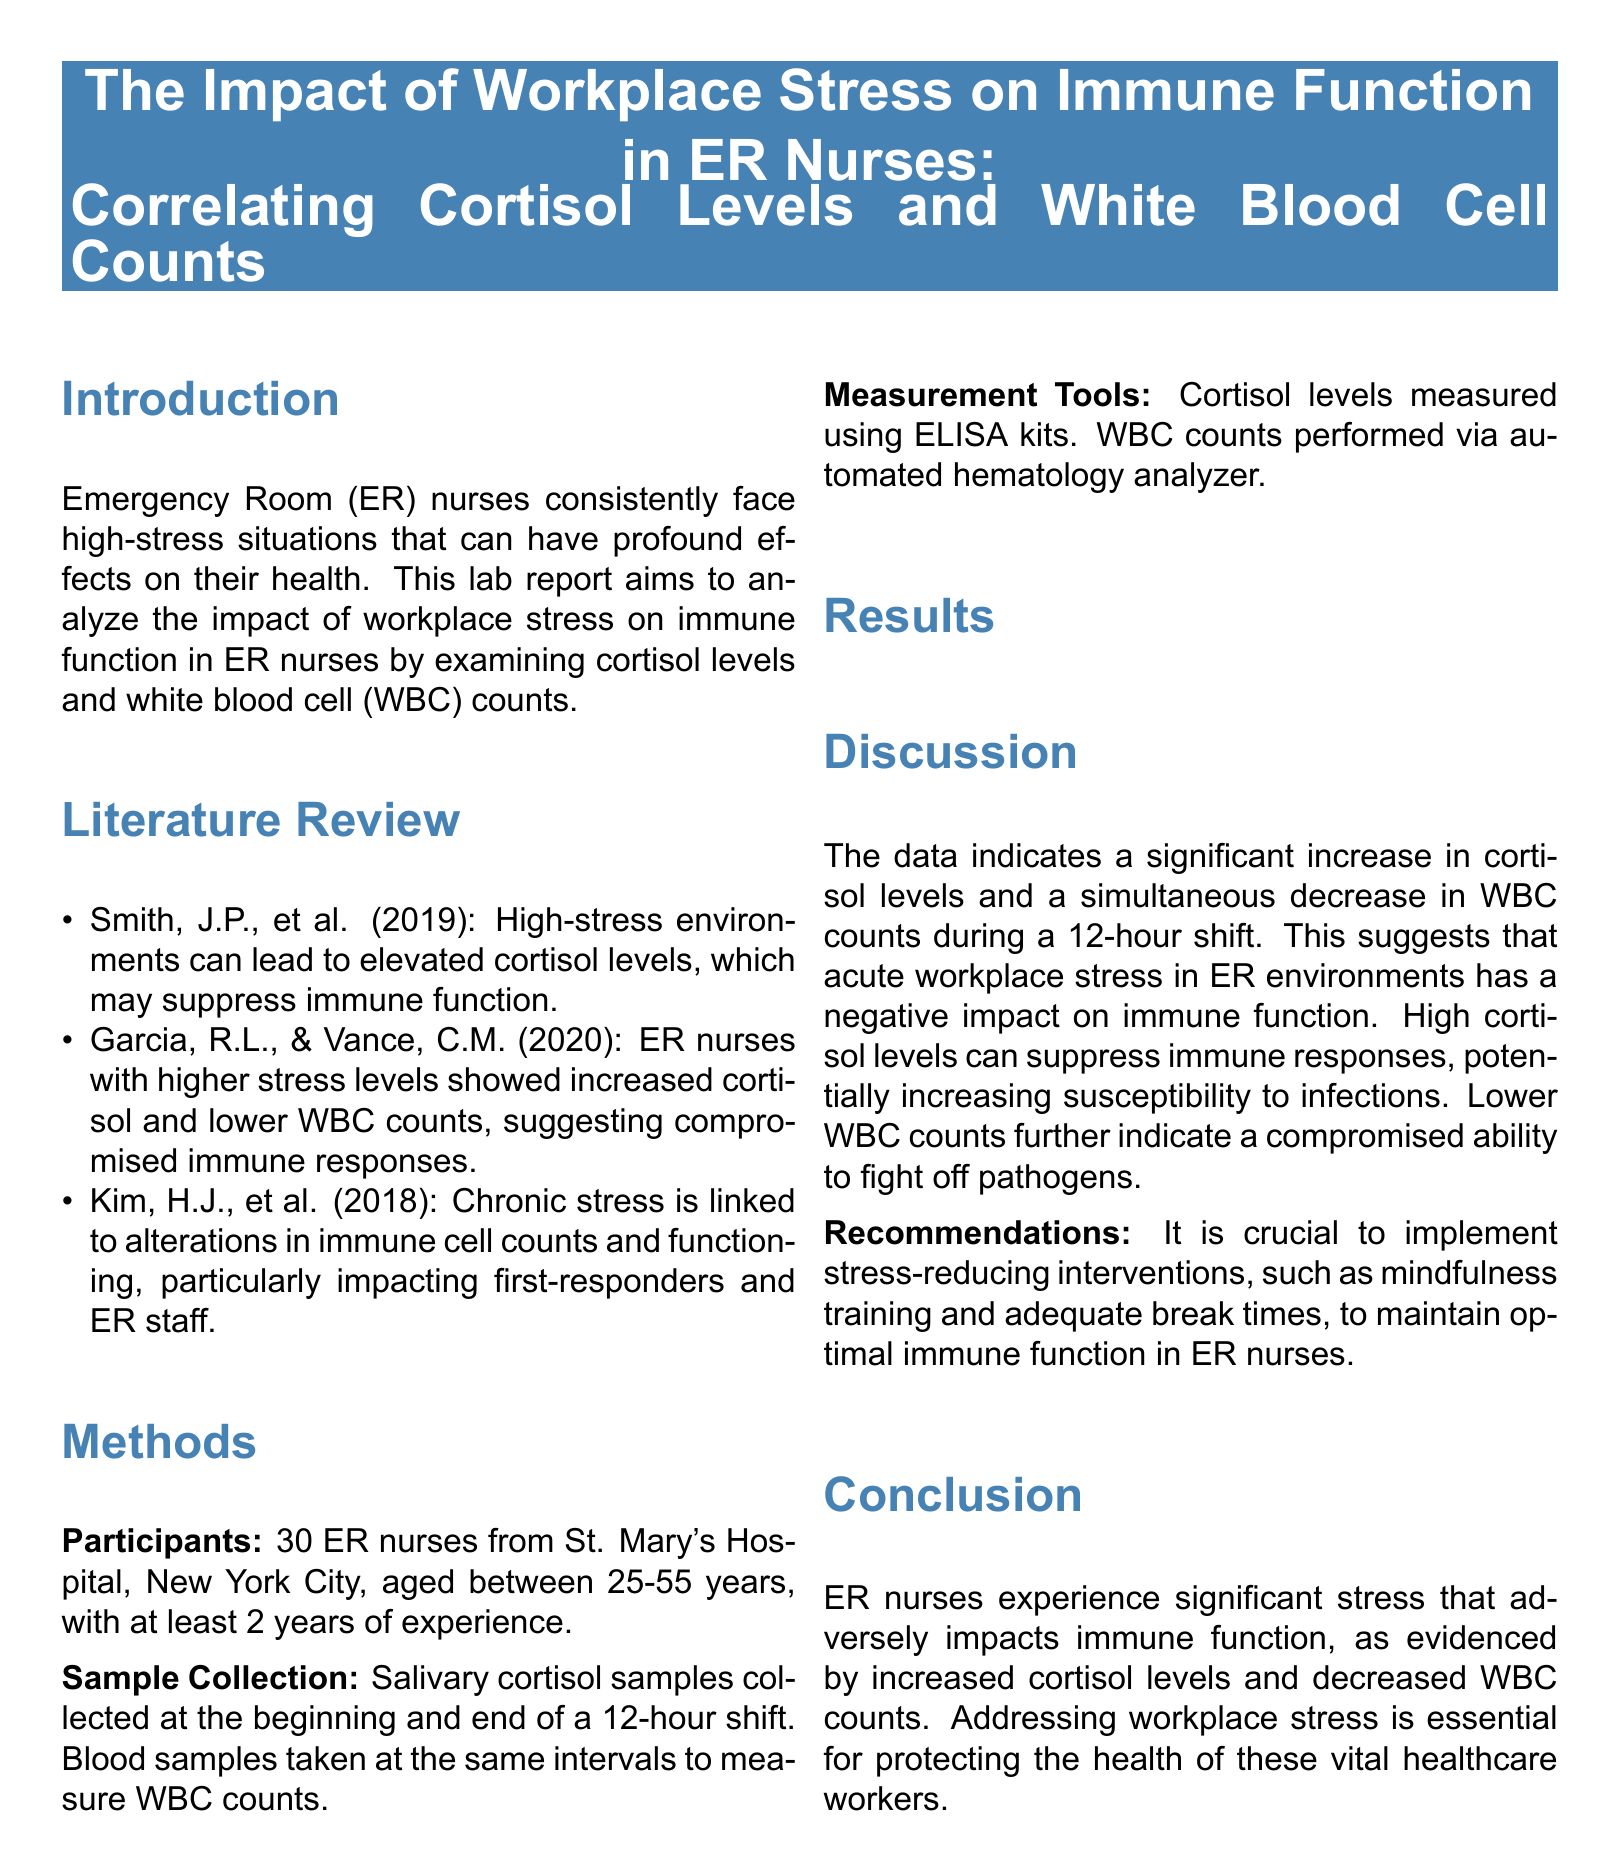What is the primary focus of the lab report? The primary focus is analyzing the impact of workplace stress on immune function in ER nurses.
Answer: Impact of workplace stress on immune function in ER nurses What was the average cortisol level before the shift? The average cortisol level before the shift is listed in the results table.
Answer: 12.5 µg/dL What is the mean WBC count after the shift? The mean WBC count after the shift is taken from the results table.
Answer: 5,900 cells/µL How many ER nurses participated in the study? The participant count is mentioned in the methods section.
Answer: 30 ER nurses What stress-reducing intervention is recommended in the report? The recommendation for stress reduction is found in the discussion section.
Answer: Mindfulness training What change occurs in cortisol levels from before to after a shift? The change from before to after the shift is highlighted in the results.
Answer: Increase What is the range of cortisol levels after the shift? The range is detailed in the results section of the report.
Answer: 15.8-30.1 µg/dL Which hospital's ER nurses were studied in the report? The name of the hospital can be found in the methods section.
Answer: St. Mary's Hospital What does the report suggest about the relationship between cortisol levels and immune responses? The relationship is discussed in the discussion section.
Answer: High cortisol levels can suppress immune responses 